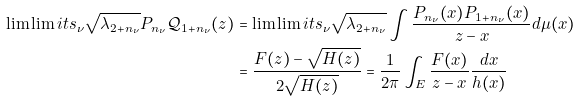<formula> <loc_0><loc_0><loc_500><loc_500>\lim \lim i t s _ { \nu } \sqrt { \lambda _ { 2 + n _ { \nu } } } P _ { n _ { \nu } } { \mathcal { Q } } _ { 1 + n _ { \nu } } ( z ) & = \lim \lim i t s _ { \nu } \sqrt { \lambda _ { 2 + n _ { \nu } } } \int \frac { P _ { n _ { \nu } } ( x ) P _ { 1 + n _ { \nu } } ( x ) } { z - x } d \mu ( x ) \\ & = \frac { F ( z ) - \sqrt { H ( z ) } } { 2 \sqrt { H ( z ) } } = \frac { 1 } { 2 \pi } \int _ { E } \frac { F ( x ) } { z - x } \frac { d x } { h ( x ) }</formula> 